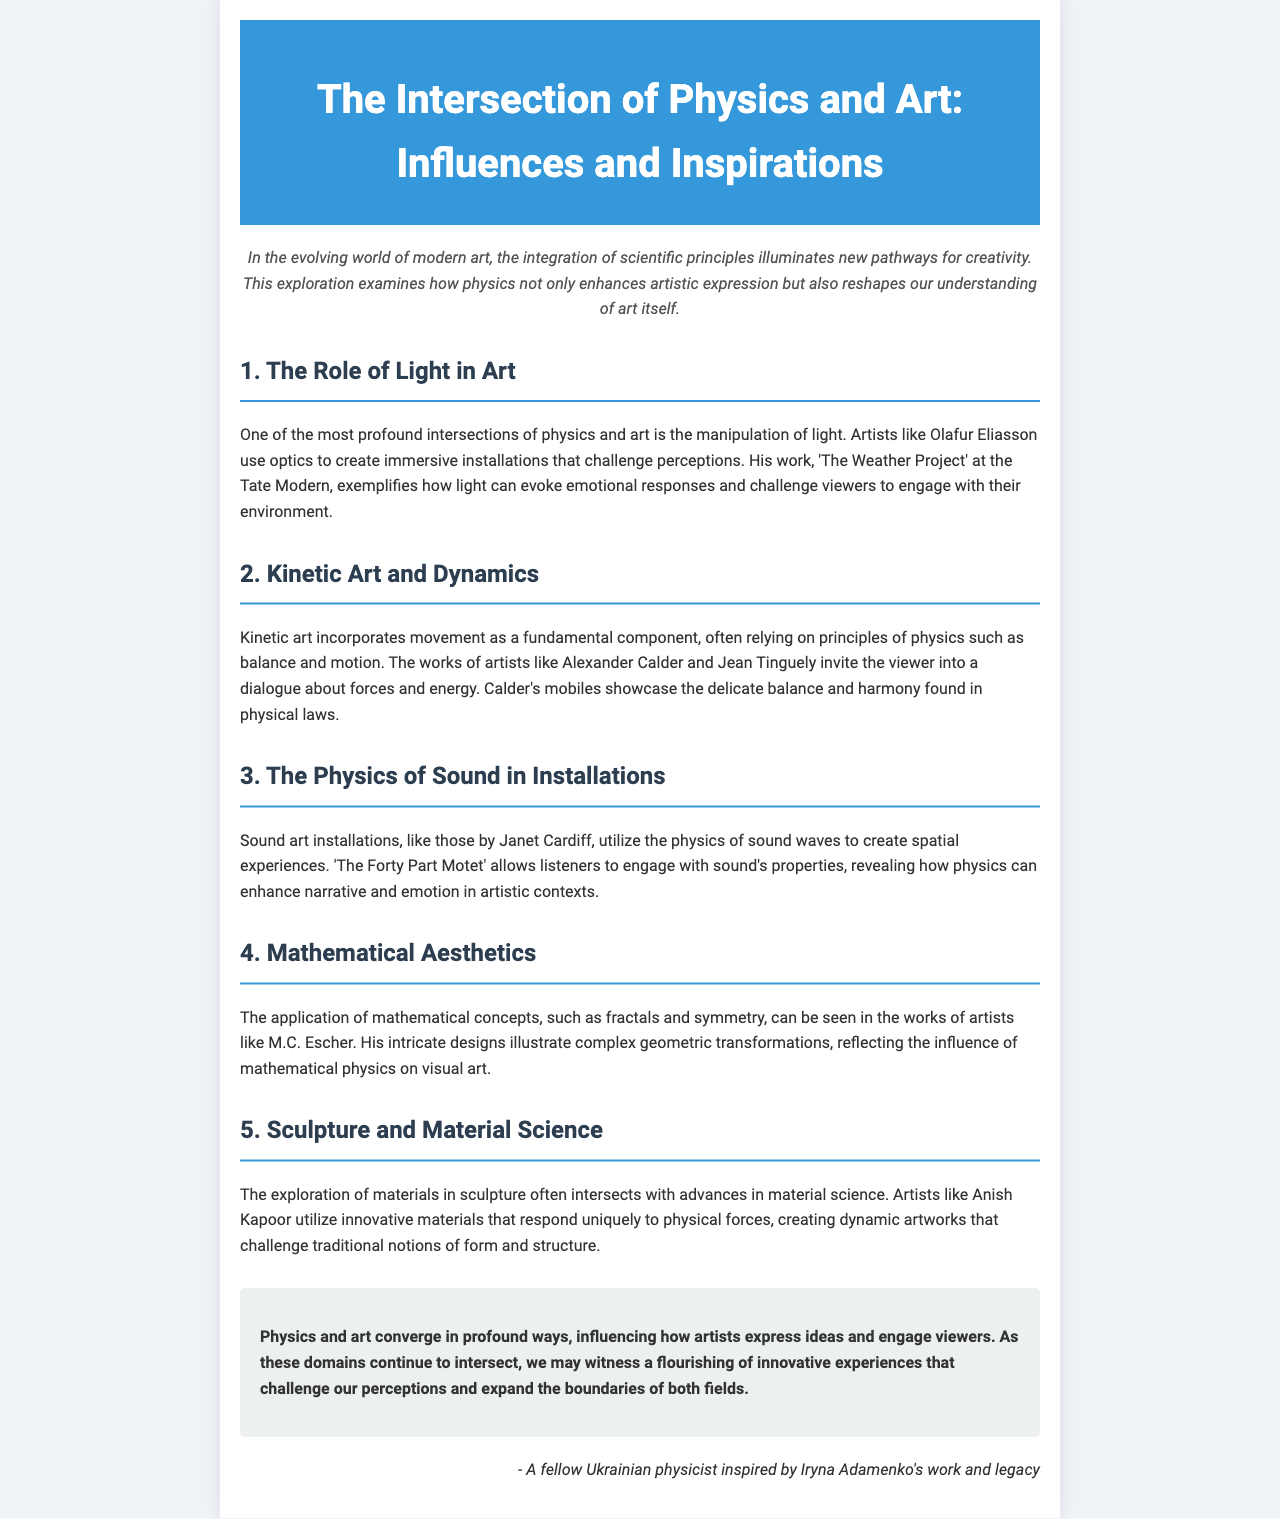What is the title of the newsletter? The title is explicitly stated at the top of the document and is “The Intersection of Physics and Art: Influences and Inspirations.”
Answer: The Intersection of Physics and Art: Influences and Inspirations Who is an artist mentioned that uses optics in installations? The document specifically mentions Olafur Eliasson as an artist who uses optics to create immersive installations.
Answer: Olafur Eliasson What is the name of the work by Olafur Eliasson at the Tate Modern? The work created by Olafur Eliasson at the Tate Modern is referred to as 'The Weather Project.'
Answer: The Weather Project Which artist is associated with kinetic art? The newsletter lists Alexander Calder as an artist known for kinetic art.
Answer: Alexander Calder What is the concept explored in M.C. Escher's works? The document discusses the application of mathematical concepts, particularly fractals and symmetry, in M.C. Escher's works.
Answer: Fractals and symmetry How does Janet Cardiff utilize sound in her installations? The document states that Janet Cardiff's work utilizes the physics of sound waves to create spatial experiences.
Answer: Physics of sound waves What is the concluding thought regarding the intersection of physics and art? The conclusion states that physics and art converge, influencing how artists express ideas and engage viewers.
Answer: Influencing expression and engagement What artistic technique is mentioned alongside Anish Kapoor's work? The document mentions that Anish Kapoor explores innovative materials in sculpture.
Answer: Innovative materials How many sections does the newsletter contain? The newsletter consists of five sections addressing different aspects of the intersection of physics and art.
Answer: Five sections 